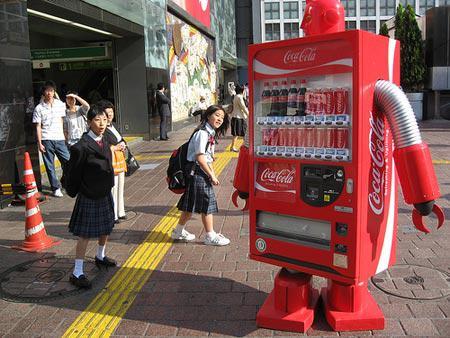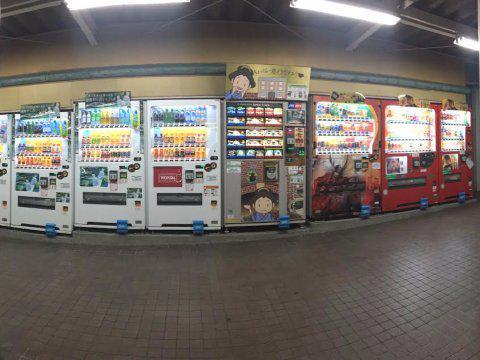The first image is the image on the left, the second image is the image on the right. Evaluate the accuracy of this statement regarding the images: "At least one image contains a vending machine that is mostly red in color.". Is it true? Answer yes or no. Yes. The first image is the image on the left, the second image is the image on the right. Analyze the images presented: Is the assertion "The right image only has one vending machine." valid? Answer yes or no. No. 